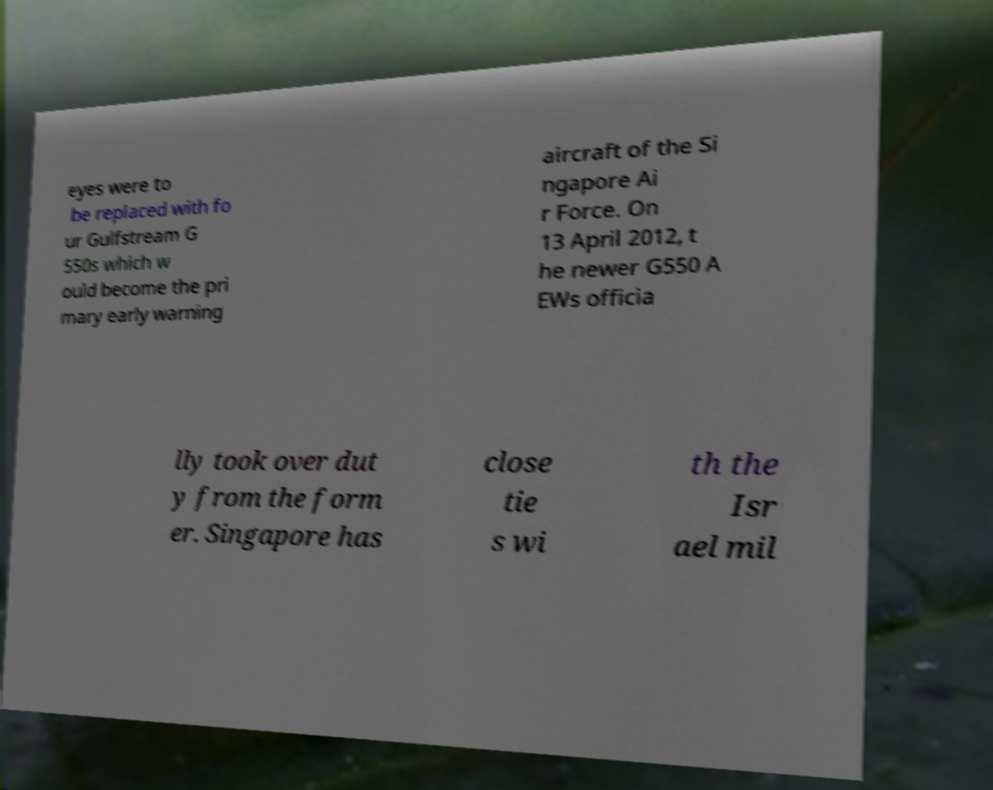Can you accurately transcribe the text from the provided image for me? eyes were to be replaced with fo ur Gulfstream G 550s which w ould become the pri mary early warning aircraft of the Si ngapore Ai r Force. On 13 April 2012, t he newer G550 A EWs officia lly took over dut y from the form er. Singapore has close tie s wi th the Isr ael mil 